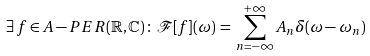<formula> <loc_0><loc_0><loc_500><loc_500>\exists \, f \in A - P E R ( \mathbb { R } , \mathbb { C } ) \, \colon \, \mathcal { F } [ f ] ( \omega ) \, = \, \sum _ { n = - \infty } ^ { + \infty } A _ { n } \delta ( \omega - \omega _ { n } )</formula> 